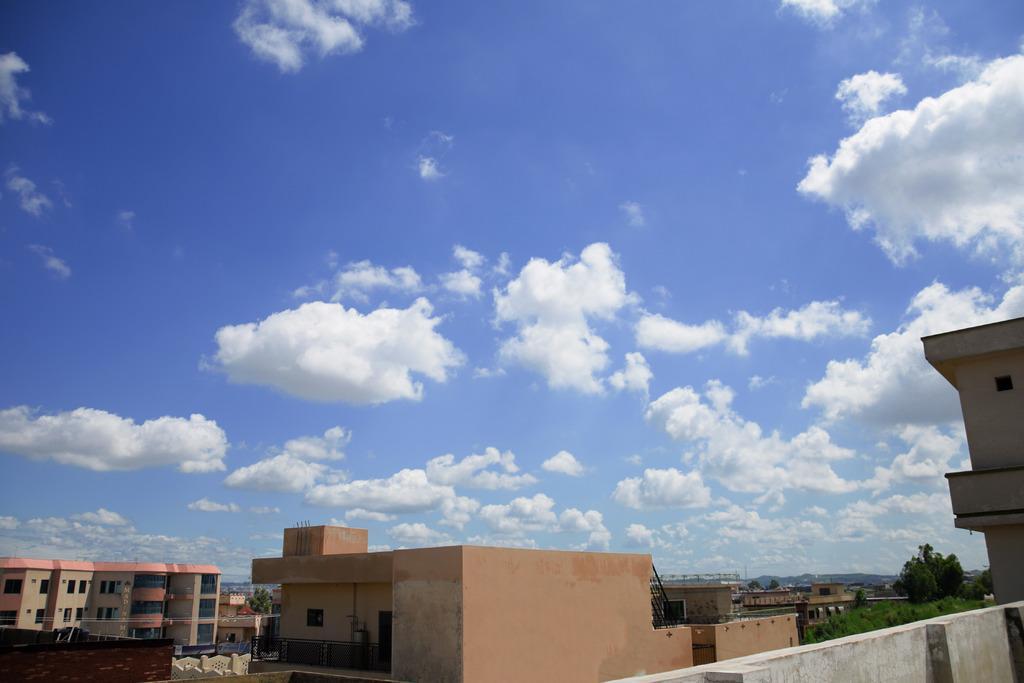Please provide a concise description of this image. In this image there are buildings and trees. Right side there are hills. Top of the image there is sky, having clouds. 